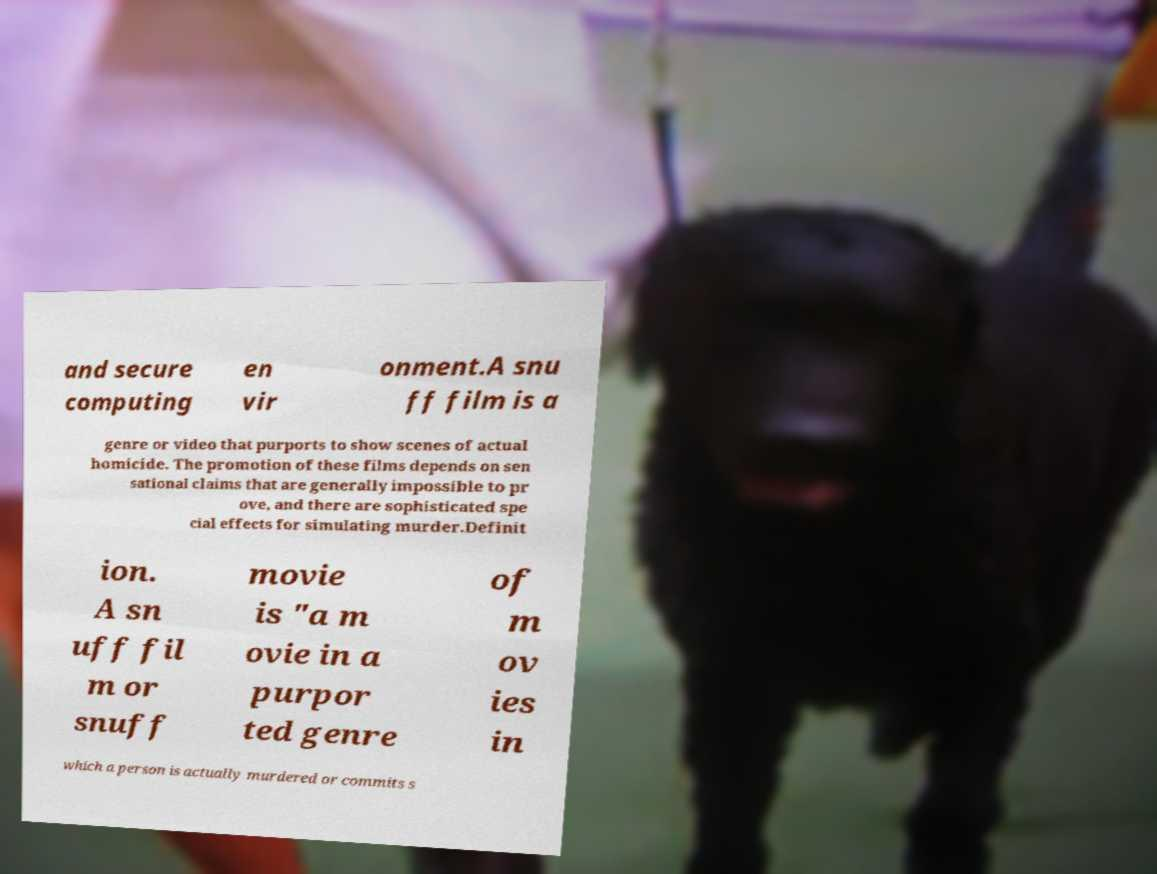For documentation purposes, I need the text within this image transcribed. Could you provide that? and secure computing en vir onment.A snu ff film is a genre or video that purports to show scenes of actual homicide. The promotion of these films depends on sen sational claims that are generally impossible to pr ove, and there are sophisticated spe cial effects for simulating murder.Definit ion. A sn uff fil m or snuff movie is "a m ovie in a purpor ted genre of m ov ies in which a person is actually murdered or commits s 